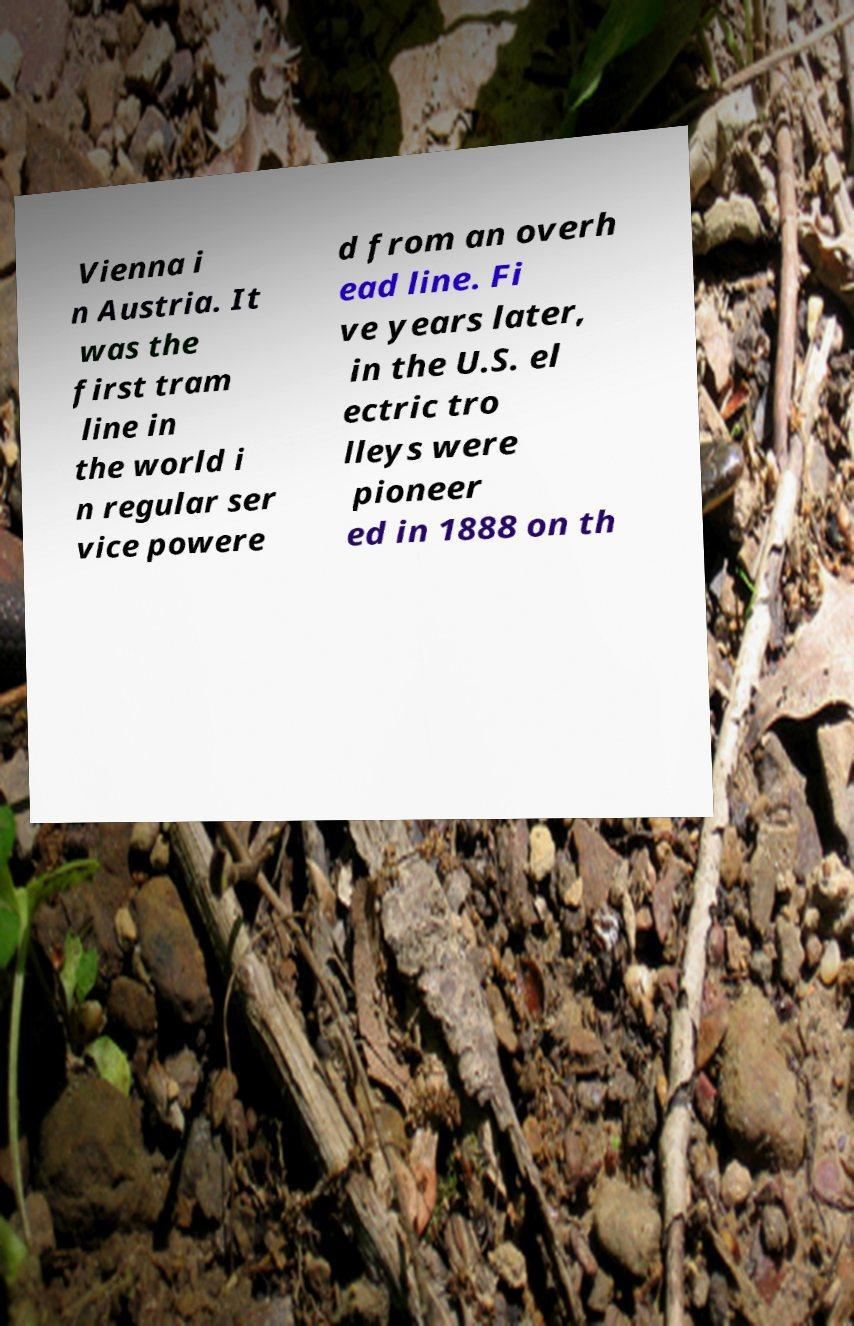There's text embedded in this image that I need extracted. Can you transcribe it verbatim? Vienna i n Austria. It was the first tram line in the world i n regular ser vice powere d from an overh ead line. Fi ve years later, in the U.S. el ectric tro lleys were pioneer ed in 1888 on th 